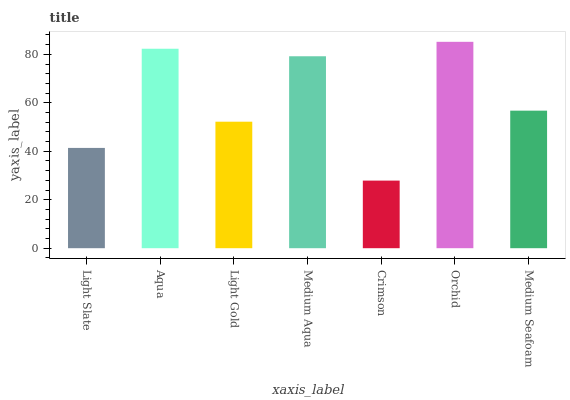Is Crimson the minimum?
Answer yes or no. Yes. Is Orchid the maximum?
Answer yes or no. Yes. Is Aqua the minimum?
Answer yes or no. No. Is Aqua the maximum?
Answer yes or no. No. Is Aqua greater than Light Slate?
Answer yes or no. Yes. Is Light Slate less than Aqua?
Answer yes or no. Yes. Is Light Slate greater than Aqua?
Answer yes or no. No. Is Aqua less than Light Slate?
Answer yes or no. No. Is Medium Seafoam the high median?
Answer yes or no. Yes. Is Medium Seafoam the low median?
Answer yes or no. Yes. Is Crimson the high median?
Answer yes or no. No. Is Medium Aqua the low median?
Answer yes or no. No. 